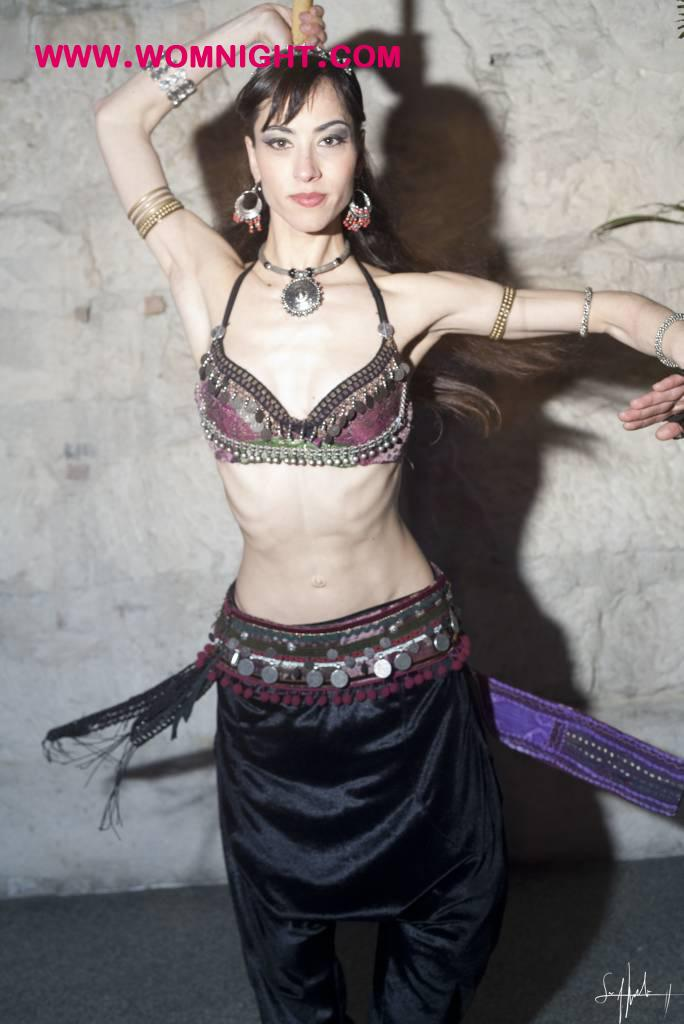Who is the main subject in the image? There is a woman in the image. What is the woman doing in the image? The woman is dancing on the floor. What can be seen behind the woman? There is a wall visible at the back of the woman. What is written or displayed at the top of the image? There is some text visible at the top of the image. What type of button is the woman's father wearing in the image? There is no button or father present in the image; it only features a woman dancing. How many sisters does the woman have in the image? There is no information about the woman's sisters in the image; it only shows her dancing. 